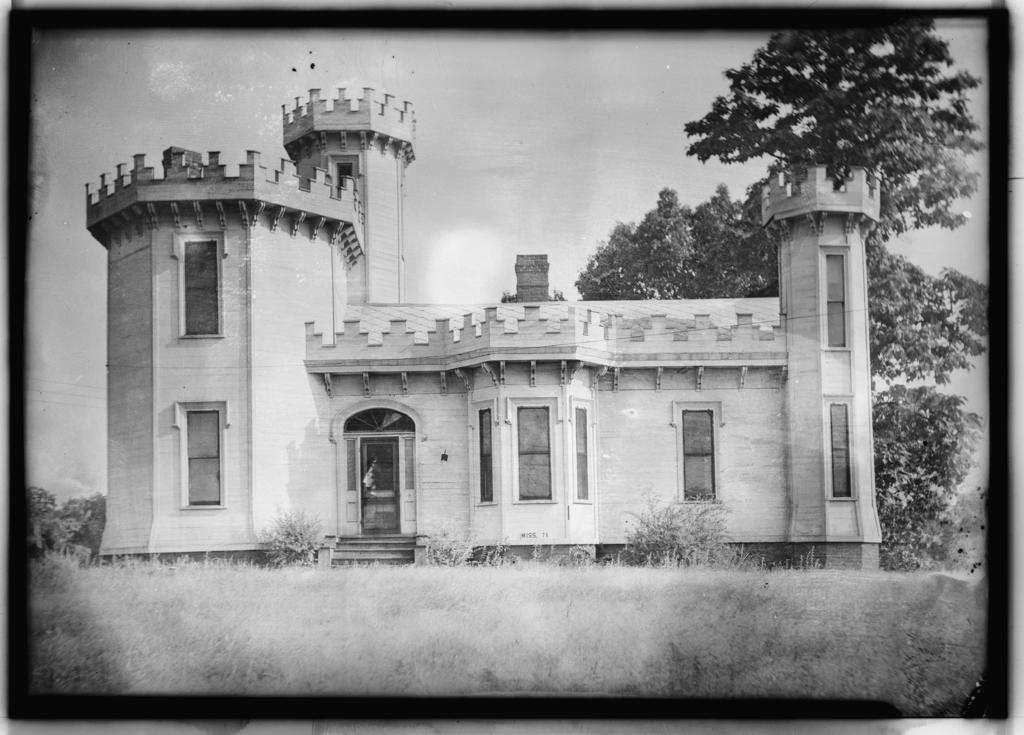What type of vegetation can be seen in the image? There are trees and grass in the image. What type of structure is present in the image? There is a building in the image. What can be seen in the sky in the image? There are clouds in the sky in the image. What type of fan is visible in the image? There is no fan present in the image. How does the popcorn contribute to the image? There is no popcorn present in the image. 